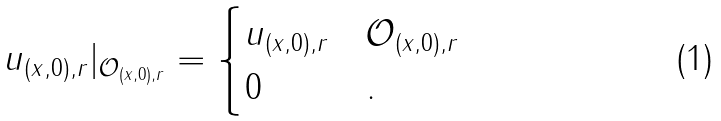<formula> <loc_0><loc_0><loc_500><loc_500>u _ { ( x , 0 ) , r } | _ { \mathcal { O } _ { ( x , 0 ) , r } } = \begin{cases} u _ { ( x , 0 ) , r } & \mathcal { O } _ { ( x , 0 ) , r } \\ 0 & . \end{cases}</formula> 